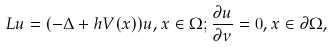<formula> <loc_0><loc_0><loc_500><loc_500>L u = ( - \Delta + h V ( x ) ) u , x \in \Omega ; \frac { \partial u } { \partial \nu } = 0 , x \in \partial \Omega ,</formula> 